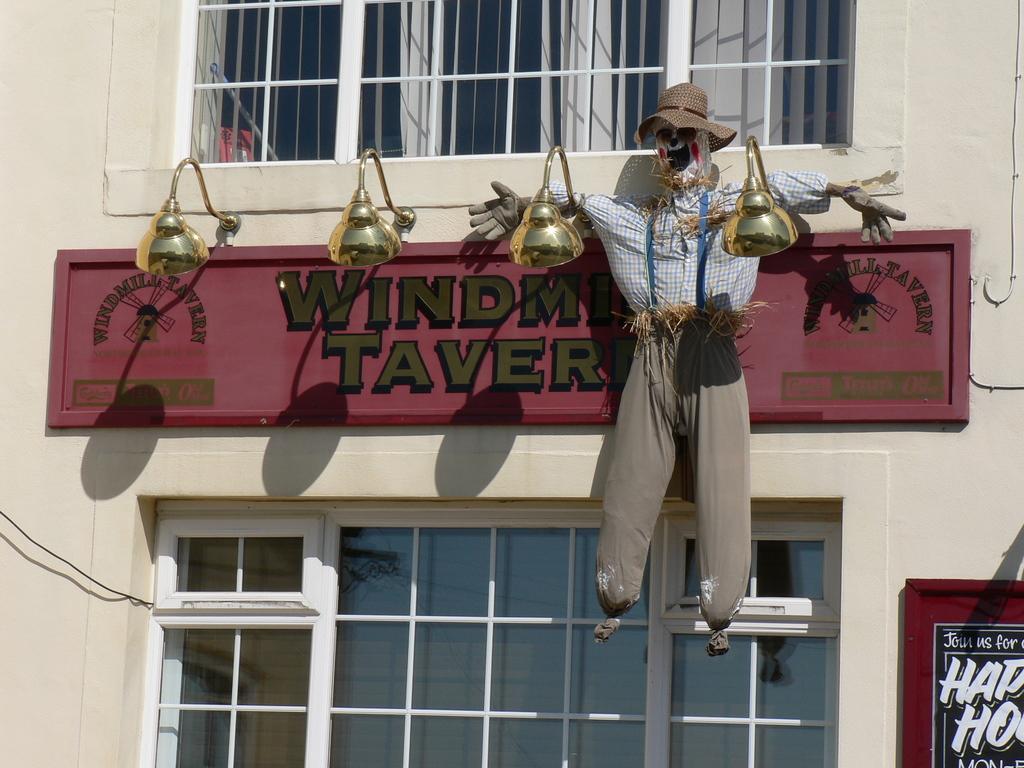Could you give a brief overview of what you see in this image? In this image I can see a building's wall and on it I can see two boards, few lights, windows and a scarecrow. I can also see something is written on these boards. 